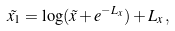Convert formula to latex. <formula><loc_0><loc_0><loc_500><loc_500>\tilde { x _ { 1 } } = \log ( \tilde { x } + e ^ { - L _ { x } } ) + L _ { x } \, ,</formula> 